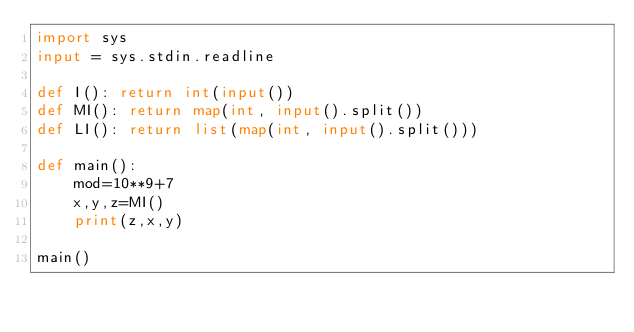Convert code to text. <code><loc_0><loc_0><loc_500><loc_500><_Python_>import sys
input = sys.stdin.readline

def I(): return int(input())
def MI(): return map(int, input().split())
def LI(): return list(map(int, input().split()))

def main():
    mod=10**9+7
    x,y,z=MI()
    print(z,x,y)

main()
</code> 